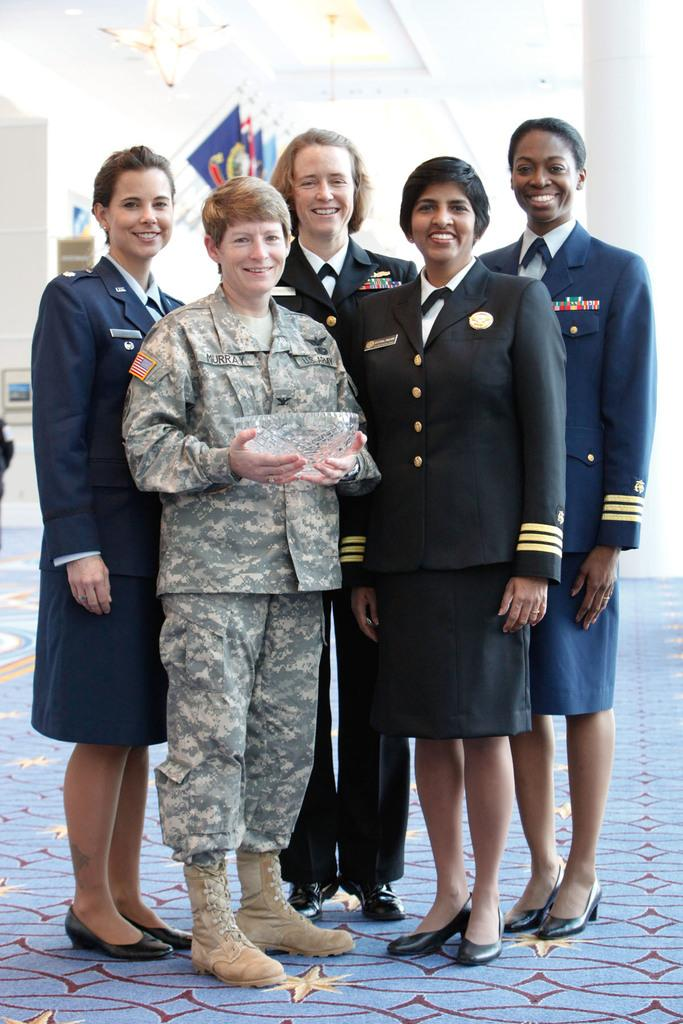What is happening in the image involving a group of people? There is a group of people in the image, and they are smiling. Can you describe the woman in the middle of the image? The woman in the middle of the image is smiling, and she is holding a bowl. What might the woman be doing with the bowl? It is not clear from the image what the woman might be doing with the bowl, but she is holding it. What type of beef can be seen hanging from the window in the image? There is no beef or window present in the image; it only features a group of people and a woman holding a bowl. 